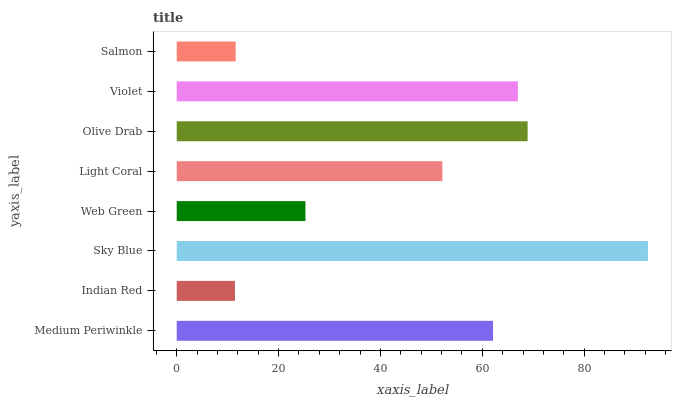Is Indian Red the minimum?
Answer yes or no. Yes. Is Sky Blue the maximum?
Answer yes or no. Yes. Is Sky Blue the minimum?
Answer yes or no. No. Is Indian Red the maximum?
Answer yes or no. No. Is Sky Blue greater than Indian Red?
Answer yes or no. Yes. Is Indian Red less than Sky Blue?
Answer yes or no. Yes. Is Indian Red greater than Sky Blue?
Answer yes or no. No. Is Sky Blue less than Indian Red?
Answer yes or no. No. Is Medium Periwinkle the high median?
Answer yes or no. Yes. Is Light Coral the low median?
Answer yes or no. Yes. Is Salmon the high median?
Answer yes or no. No. Is Medium Periwinkle the low median?
Answer yes or no. No. 